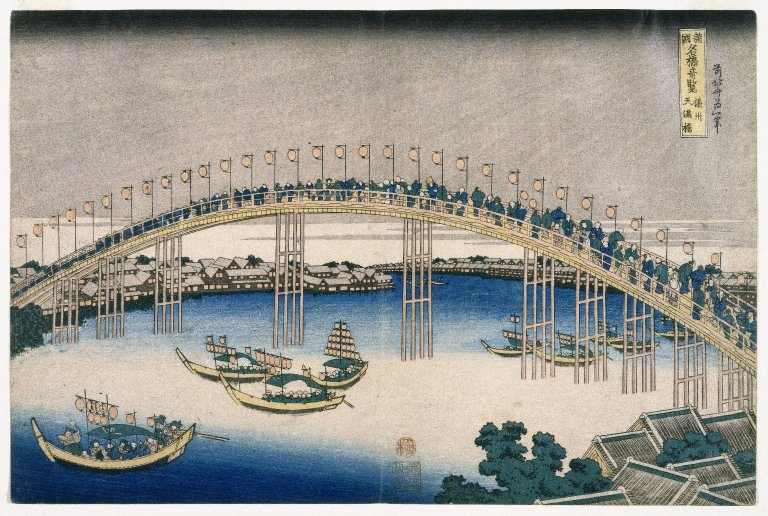What does this bridge and the river signify in the context of Edo period Japan? In Edo period Japan, bridges like the one depicted were not only crucial for the physical connectivity of expanding cities like Tokyo but also symbolized the burgeoning societal changes. The river, often bustling with boats, represents commerce and the vibrant trade system vital to Japan's economy at that time. This bridge, being a focal point of transit, exemplifies the blend of functionality and aesthetic appeal, highlighting the technological advancements and cultural flourishing of the era. 